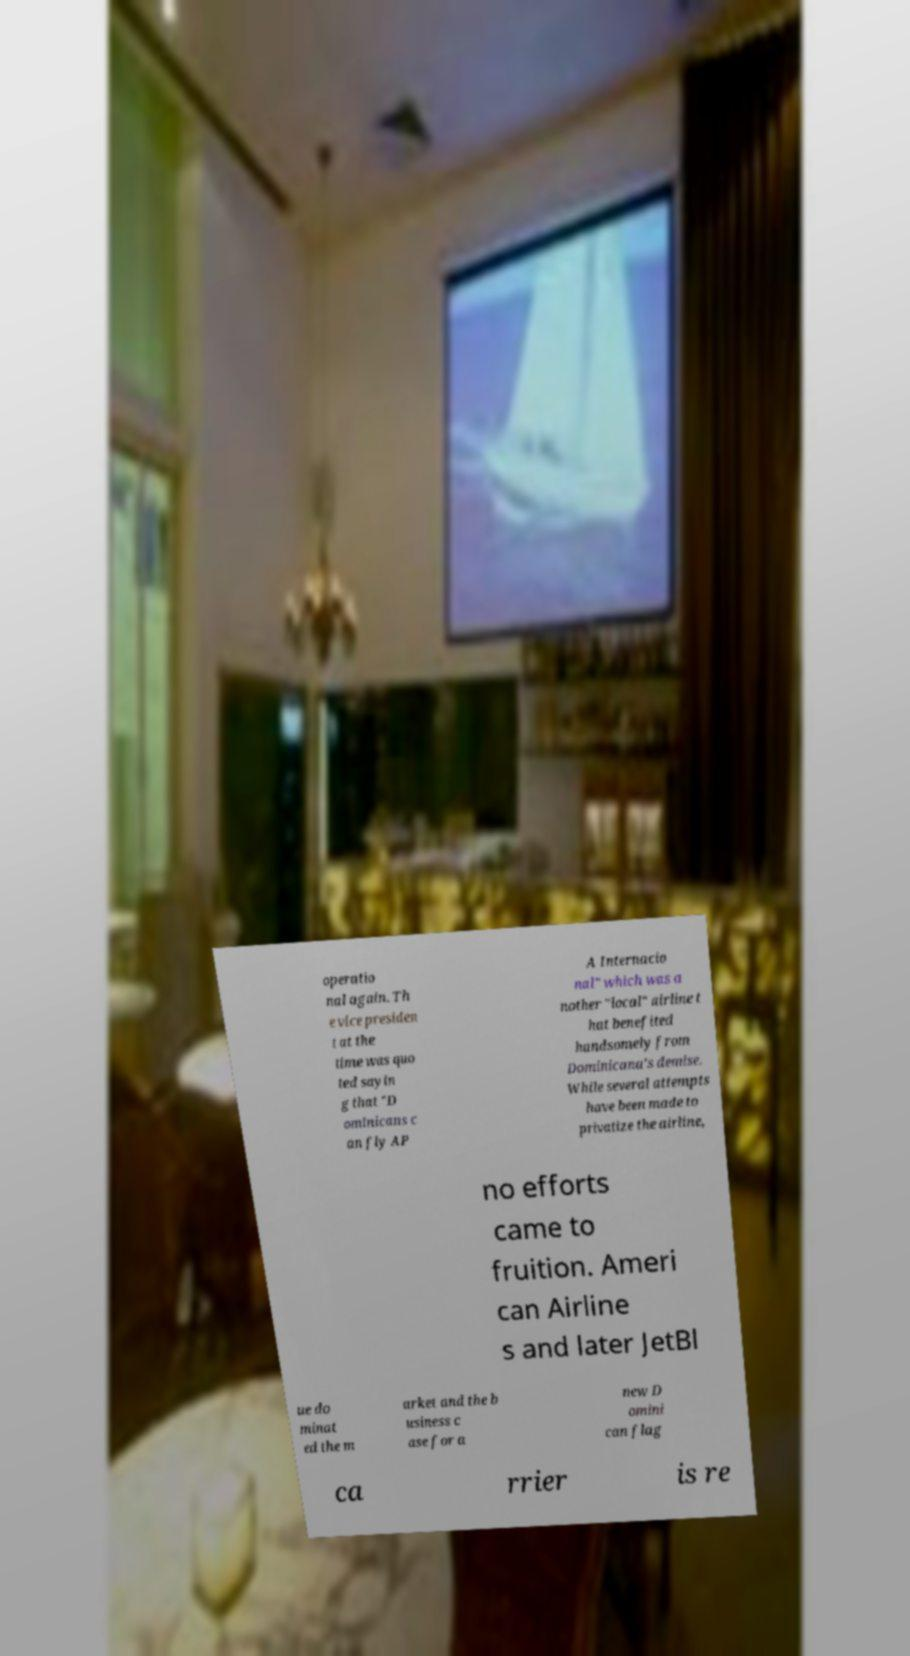I need the written content from this picture converted into text. Can you do that? operatio nal again. Th e vice presiden t at the time was quo ted sayin g that "D ominicans c an fly AP A Internacio nal" which was a nother "local" airline t hat benefited handsomely from Dominicana's demise. While several attempts have been made to privatize the airline, no efforts came to fruition. Ameri can Airline s and later JetBl ue do minat ed the m arket and the b usiness c ase for a new D omini can flag ca rrier is re 